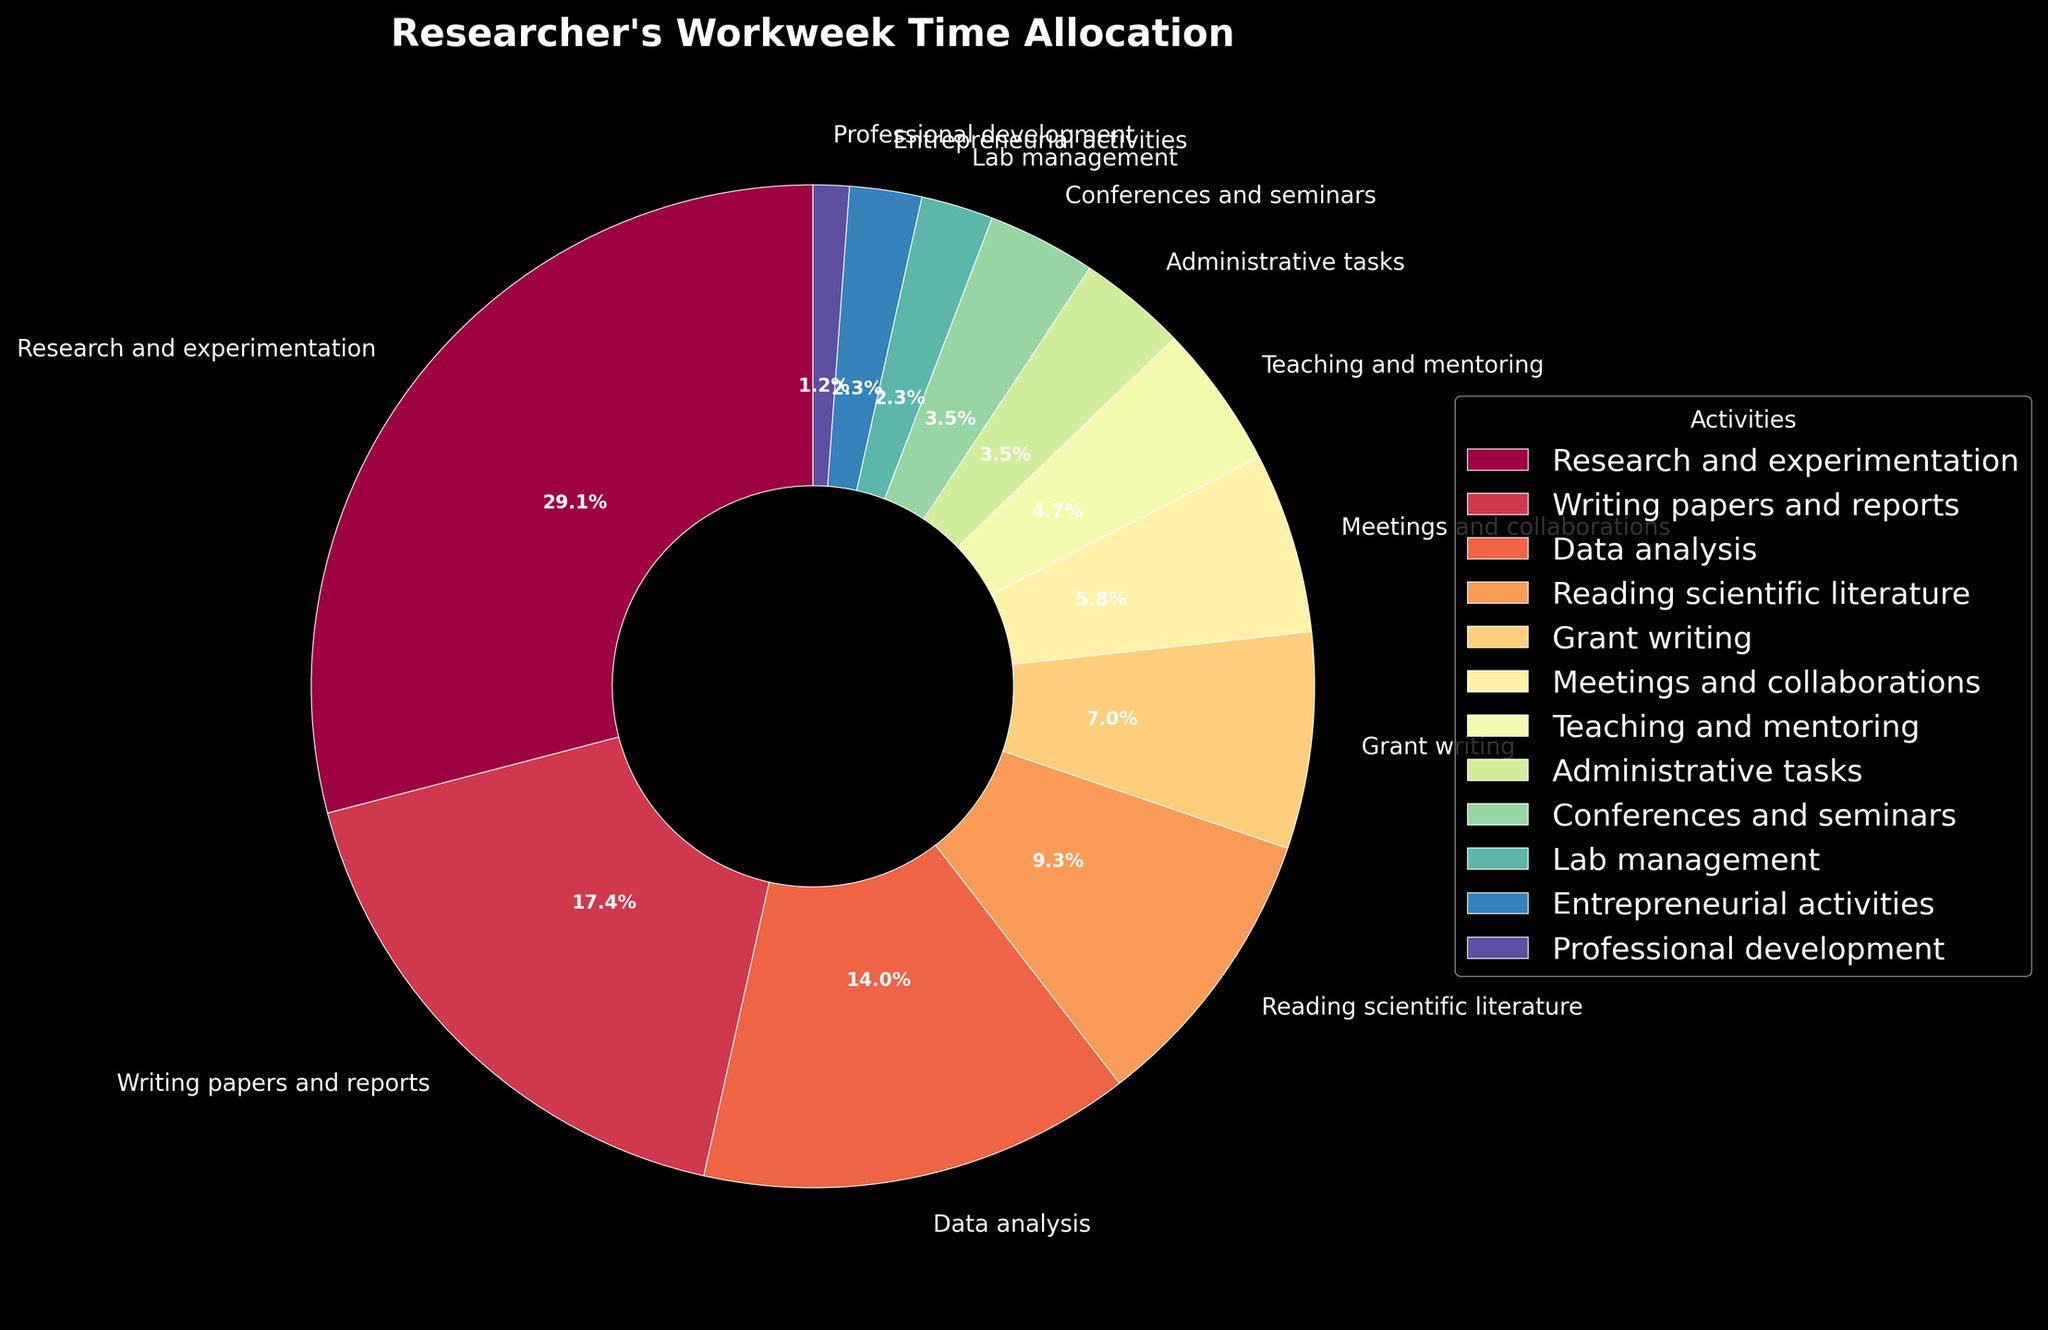What percentage of the workweek is spent on Research and Experimentation? Locate the slice labeled "Research and Experimentation" on the pie chart and read the percentage value shown.
Answer: 37.3% How many hours are allocated to Data Analysis and Reading Scientific Literature combined? Find the slices labeled "Data Analysis" and "Reading Scientific Literature," note their hours (12 and 8 respectively), and add them together.
Answer: 20 Which activity has the smallest allocation of time? Identify the smallest slice in the pie chart and read its label.
Answer: Professional development Are more hours spent on Meetings and Collaborations or on Teaching and Mentoring? Locate the slices for "Meetings and Collaborations" and "Teaching and Mentoring," compare their hours (5 and 4 respectively).
Answer: Meetings and Collaborations What is the ratio of the hours spent on Grant Writing to Administrative Tasks? Find the slices labeled "Grant Writing" and "Administrative Tasks," note their hours (6 and 3 respectively), and then calculate the ratio 6:3, which simplifies to 2:1.
Answer: 2:1 Which three activities take up the most time, and how much time in total do they consume? Identify the three largest slices, labeled "Research and Experimentation," "Writing papers and reports," and "Data Analysis." Sum their hours (25 + 15 + 12).
Answer: Research and Experimentation, Writing papers and reports, Data Analysis; 52 How does the time allocated to Entrepreneurial Activities compare to Professional Development? Locate the slices for "Entrepreneurial Activities" and "Professional Development," compare their hours (2 and 1 respectively).
Answer: Twice as much Is the time spent on Administrative Tasks greater or less than that spent on Conferences and Seminars? Compare the hours of "Administrative Tasks" (3) and "Conferences and Seminars" (3).
Answer: Equal How much more time is spent on Writing Papers and Reports compared to Teaching and Mentoring? Locate the slices labeled "Writing papers and reports" and "Teaching and mentoring," subtract the hours of Teaching and Mentoring (4) from Writing Papers and Reports (15).
Answer: 11 What is the average time allocated to the top five activities? Identify the top five slices: "Research and Experimentation" (25), "Writing papers and reports" (15), "Data Analysis" (12), "Reading scientific literature" (8), and "Grant writing" (6). Sum these hours (25 + 15 + 12 + 8 + 6 = 66) and divide by 5 for the average.
Answer: 13.2 